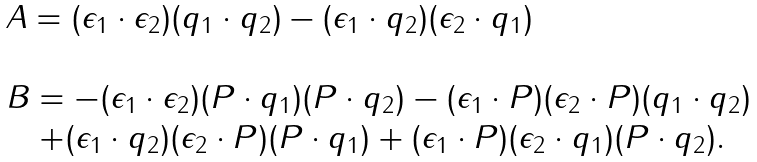Convert formula to latex. <formula><loc_0><loc_0><loc_500><loc_500>\begin{array} { l } A = ( \epsilon _ { 1 } \cdot \epsilon _ { 2 } ) ( q _ { 1 } \cdot q _ { 2 } ) - ( \epsilon _ { 1 } \cdot q _ { 2 } ) ( \epsilon _ { 2 } \cdot q _ { 1 } ) \\ \\ B = - ( \epsilon _ { 1 } \cdot \epsilon _ { 2 } ) ( P \cdot q _ { 1 } ) ( P \cdot q _ { 2 } ) - ( \epsilon _ { 1 } \cdot P ) ( \epsilon _ { 2 } \cdot P ) ( q _ { 1 } \cdot q _ { 2 } ) \\ \quad + ( \epsilon _ { 1 } \cdot q _ { 2 } ) ( \epsilon _ { 2 } \cdot P ) ( P \cdot q _ { 1 } ) + ( \epsilon _ { 1 } \cdot P ) ( \epsilon _ { 2 } \cdot q _ { 1 } ) ( P \cdot q _ { 2 } ) . \end{array}</formula> 